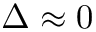Convert formula to latex. <formula><loc_0><loc_0><loc_500><loc_500>\Delta \approx 0</formula> 